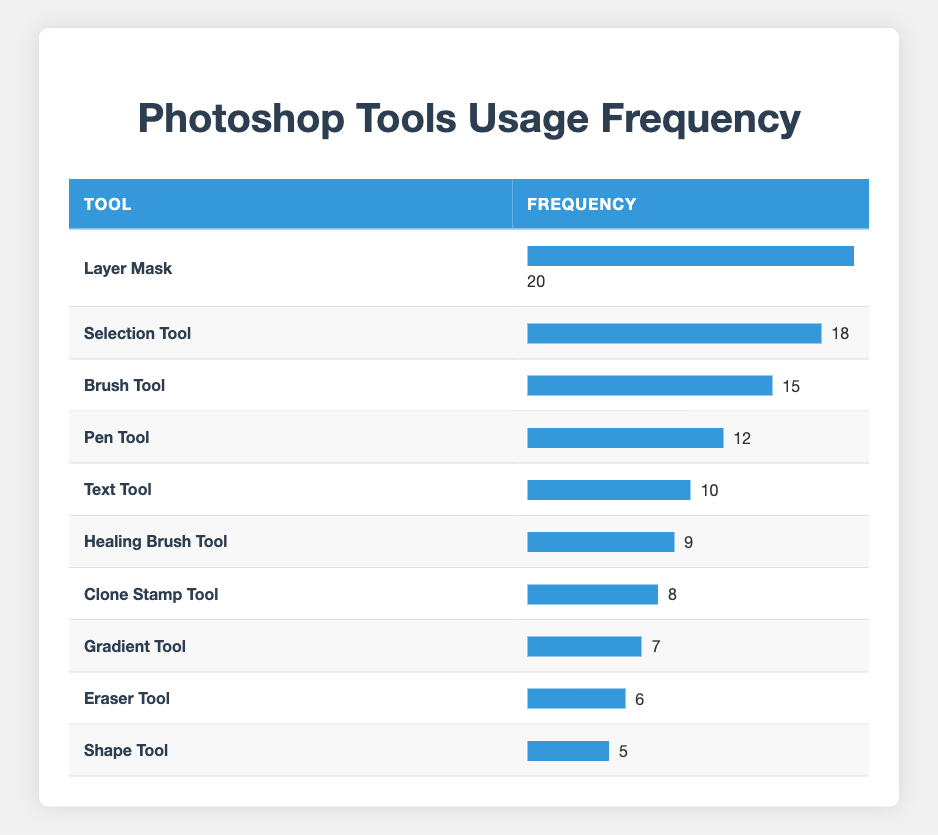What is the most frequently used tool? The tool with the highest frequency in the table is "Layer Mask," which has a frequency of 20.
Answer: Layer Mask How many times was the Eraser Tool used? The table shows that the Eraser Tool was used 6 times.
Answer: 6 Which tool was used more, the Healing Brush Tool or the Clone Stamp Tool? The Healing Brush Tool has a frequency of 9, while the Clone Stamp Tool has a frequency of 8. Therefore, the Healing Brush Tool was used more.
Answer: Healing Brush Tool What is the total frequency of the top three tools (Layer Mask, Selection Tool, and Brush Tool)? The frequency of Layer Mask is 20, Selection Tool is 18, and Brush Tool is 15. Adding these gives 20 + 18 + 15 = 53.
Answer: 53 Is the frequency of the Gradient Tool greater than that of the Shape Tool? The Gradient Tool has a frequency of 7 and the Shape Tool has a frequency of 5. Since 7 is greater than 5, the statement is true.
Answer: Yes What is the average frequency of all the tools listed? There are 10 tools in total. The frequencies are 20, 18, 15, 12, 10, 9, 8, 7, 6, and 5. Summing these gives 20 + 18 + 15 + 12 + 10 + 9 + 8 + 7 + 6 + 5 = 110. Dividing by 10 (the number of tools) gives an average of 110/10 = 11.
Answer: 11 Which tool is least frequently used? The tool with the smallest frequency in the table is "Shape Tool," which has a frequency of 5.
Answer: Shape Tool How many tools have a frequency of 10 or more? The tools with a frequency of 10 or more are Layer Mask, Selection Tool, Brush Tool, Pen Tool, and Text Tool. This totals to 5 tools.
Answer: 5 What is the difference in frequency between the most and least used tools? The most used tool, Layer Mask, has a frequency of 20, while the least used tool, Shape Tool, has a frequency of 5. The difference is 20 - 5 = 15.
Answer: 15 